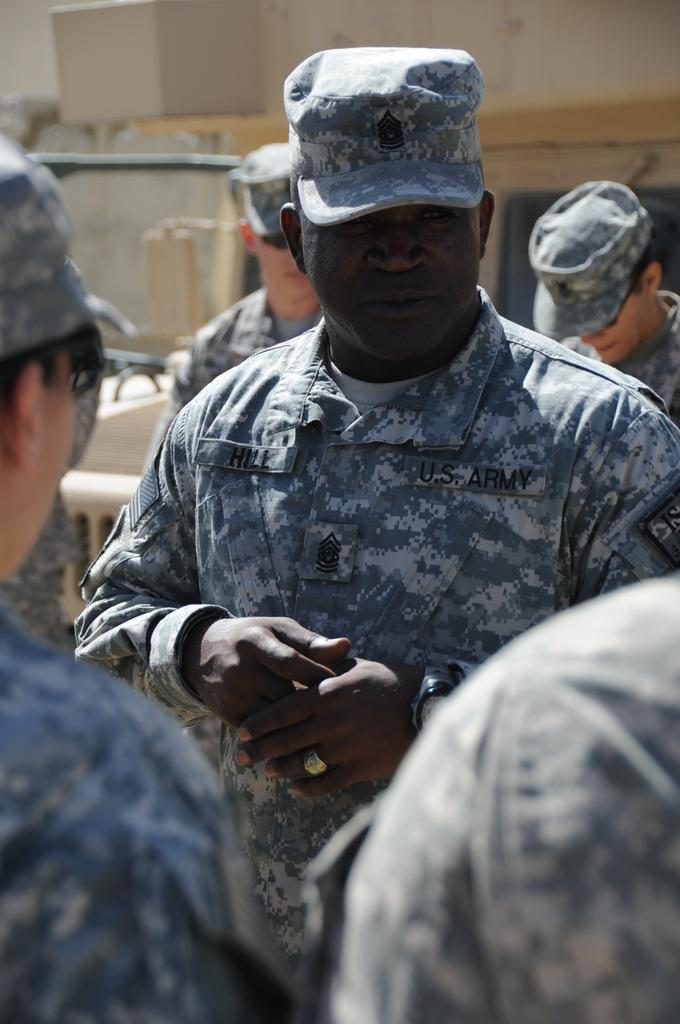What is the main subject of the image? The main subject of the image is a group of people. What are the people in the image doing? The people are standing. What are the people wearing in the image? The people are wearing uniforms. What can be seen in the background of the image? There is a building in the background of the image. What is the color of the building in the image? The building is cream-colored. What type of drink is being served by the fireman in the image? There is no fireman or drink present in the image. What is the source of the steam coming from the building in the image? There is no steam present in the image. 